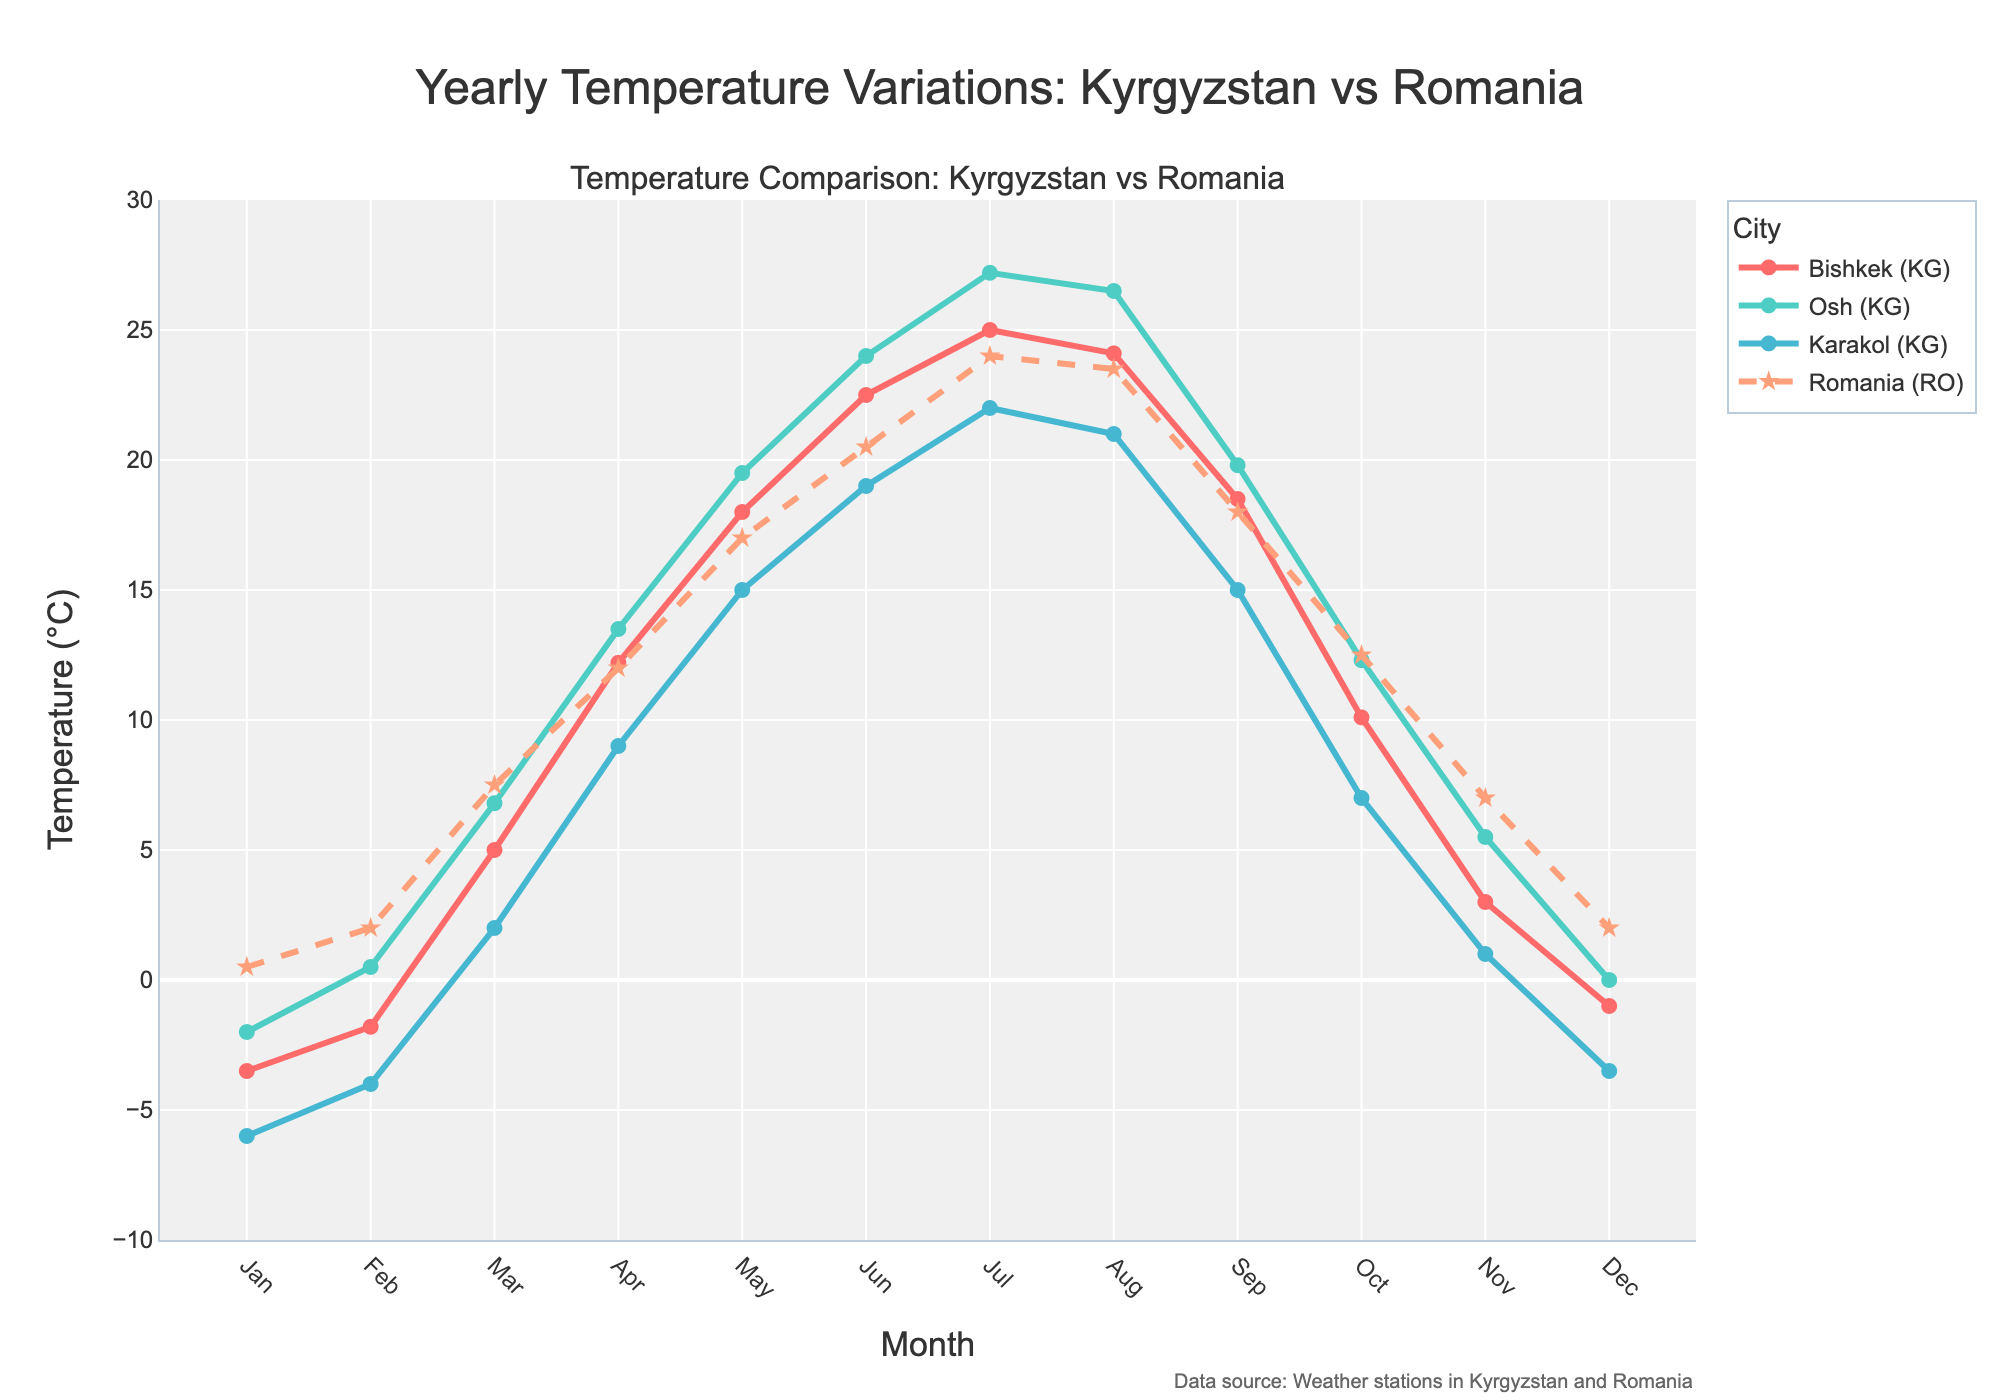Which city in Kyrgyzstan experiences the lowest average temperature in January? Look for the city with the lowest point on the graph for January on the left side. Karakol shows the lowest value at -6.0°C.
Answer: Karakol What is the highest temperature recorded in Kyrgyzstan throughout the year? Find the peak values for each city in the middle of the year. The highest peak is for Osh in July at 27.2°C.
Answer: 27.2°C How does the average temperature in Bishkek compare to Romania in December? Compare the temperature values of Bishkek and Romania at the December point on the graph. Bishkek has -1.0°C, and Romania has 2.0°C.
Answer: Bishkek is colder Which month does Osh have a higher temperature than Bishkek? Compare the monthly temperatures of Osh and Bishkek. In August, Osh's 26.5°C is higher than Bishkek's 24.1°C.
Answer: August In which months is Karakol's average temperature higher than Romania's? Assess when Karakol's trend line is above Romania’s. Karakol is always lower or equal to Romania's; hence, there are no such months.
Answer: None What is the temperature difference between Osh and Karakol in July? Find and subtract the temperatures of Osh and Karakol in July. Osh: 27.2°C, Karakol: 22.0°C. Difference is 27.2 - 22.0 = 5.2°C.
Answer: 5.2°C Which city has the most consistent temperature variation throughout the year? Look for the city whose line appears the smoothest without drastic changes. Karakol shows more consistent variations as its line is the most stable.
Answer: Karakol How does the temperature trend of Kyrgyz cities compare to Romania in the summer months (June, July, August)? Evaluate the graph in the summer period. Kyrgyz cities generally have slightly higher temperatures than Romania during these months.
Answer: Slightly higher Which month shows the greatest temperature difference between Kyrgyzstan and Romania? Compare the temperature differences month by month; the greatest visual difference is in July, where Romania's 24.0°C significantly differs from Osh's 27.2°C.
Answer: July 